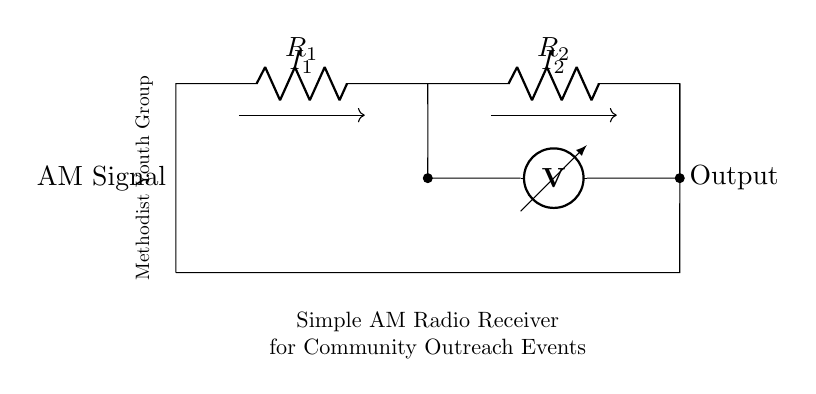What components are present in the circuit? The components visible in the circuit diagram are an antenna, two resistors labeled R1 and R2, and a voltmeter.
Answer: antenna, R1, R2, voltmeter What does the output represent in the circuit? The output signifies the point after the resistors where the processed AM signal is measured, which can be read by the voltmeter.
Answer: processed AM signal What is the role of R1 and R2 in this circuit? R1 and R2 act as current dividers, allowing the total current to be split based on their resistance values, which is crucial for adjusting the signal strength.
Answer: current dividers How is the current divided between R1 and R2? The current is divided based on the resistance values of R1 and R2, following the current divider rule, where the current through each resistor is inversely proportional to its resistance.
Answer: inversely proportional What is the significance of connecting the voltmeter in this circuit? The voltmeter is connected to measure the voltage drop across R2, which reflects the output signal strength from the AM signal received.
Answer: measuring signal strength Which component connects the antenna to the resistors? The antenna connects directly to the first resistor R1 in the circuit.
Answer: R1 What type of circuit configuration is this? This circuit is configured as a current divider, specifically designed to manage the split of current between resistors in order to optimize signal processing.
Answer: current divider 